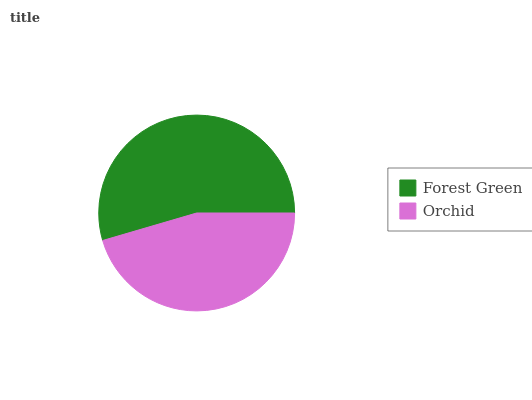Is Orchid the minimum?
Answer yes or no. Yes. Is Forest Green the maximum?
Answer yes or no. Yes. Is Orchid the maximum?
Answer yes or no. No. Is Forest Green greater than Orchid?
Answer yes or no. Yes. Is Orchid less than Forest Green?
Answer yes or no. Yes. Is Orchid greater than Forest Green?
Answer yes or no. No. Is Forest Green less than Orchid?
Answer yes or no. No. Is Forest Green the high median?
Answer yes or no. Yes. Is Orchid the low median?
Answer yes or no. Yes. Is Orchid the high median?
Answer yes or no. No. Is Forest Green the low median?
Answer yes or no. No. 